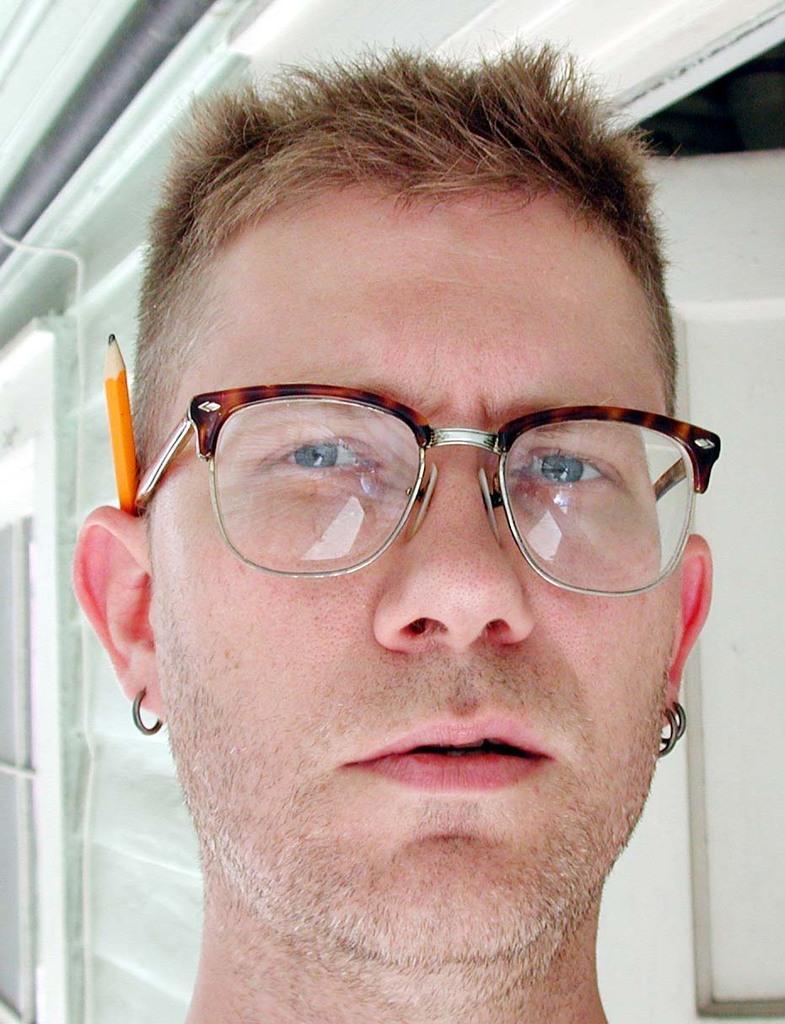Could you give a brief overview of what you see in this image? In the center of the image we can see a man is wearing the earrings, spectacles, pencil. In the background of the image we can see the wall and doors. At the top of the image we can see the roof and pipe. 